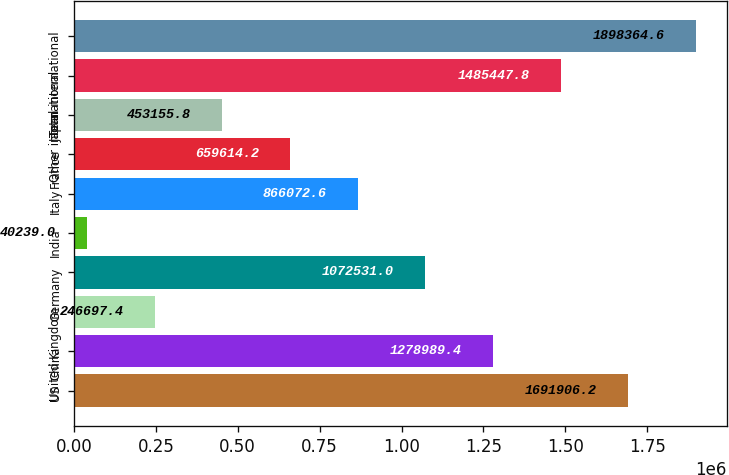<chart> <loc_0><loc_0><loc_500><loc_500><bar_chart><fcel>US<fcel>China<fcel>United Kingdom<fcel>Germany<fcel>India<fcel>Italy<fcel>France<fcel>Japan<fcel>Other international<fcel>Total international<nl><fcel>1.69191e+06<fcel>1.27899e+06<fcel>246697<fcel>1.07253e+06<fcel>40239<fcel>866073<fcel>659614<fcel>453156<fcel>1.48545e+06<fcel>1.89836e+06<nl></chart> 